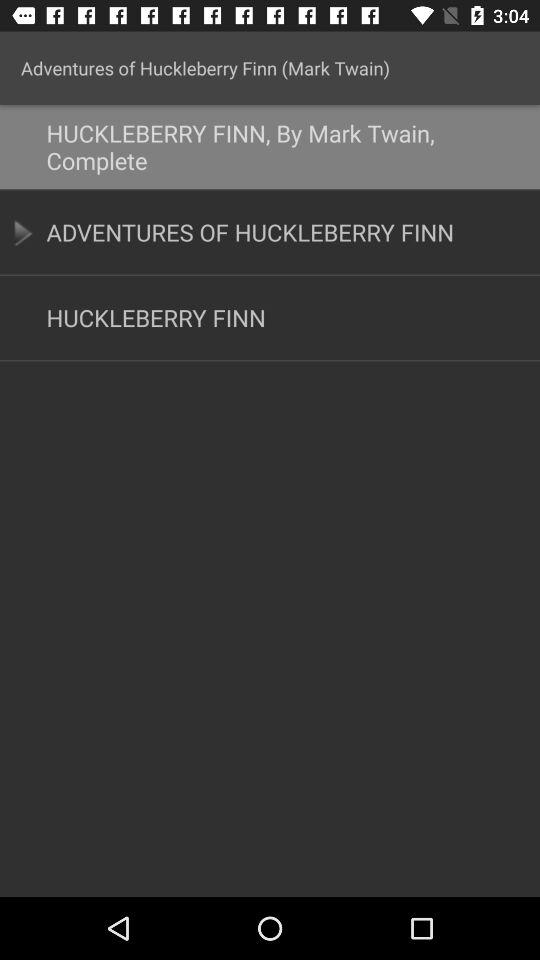Who has written the novel "Adventures of Huckleberry Finn"? The novel "Adventures of Huckleberry Finn" was written by Mark Twain. 